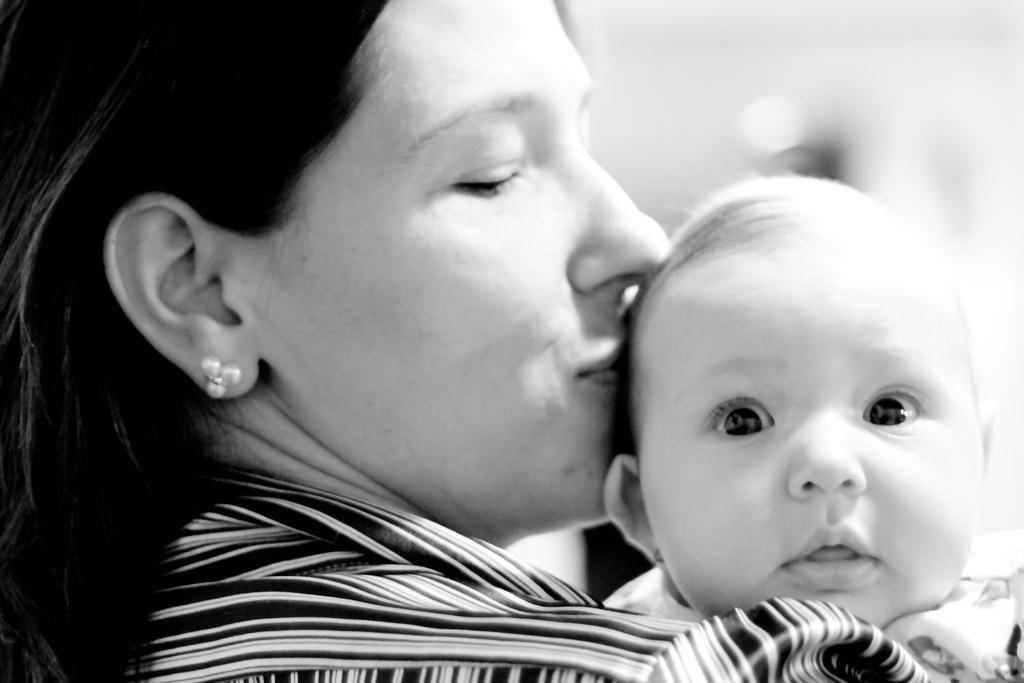Who is in the image? There is a woman in the image. What is the woman doing in the image? The woman is kissing a child. What type of fang can be seen in the woman's mouth during the kiss? There is no fang visible in the woman's mouth during the kiss, as the image does not depict any fangs. 